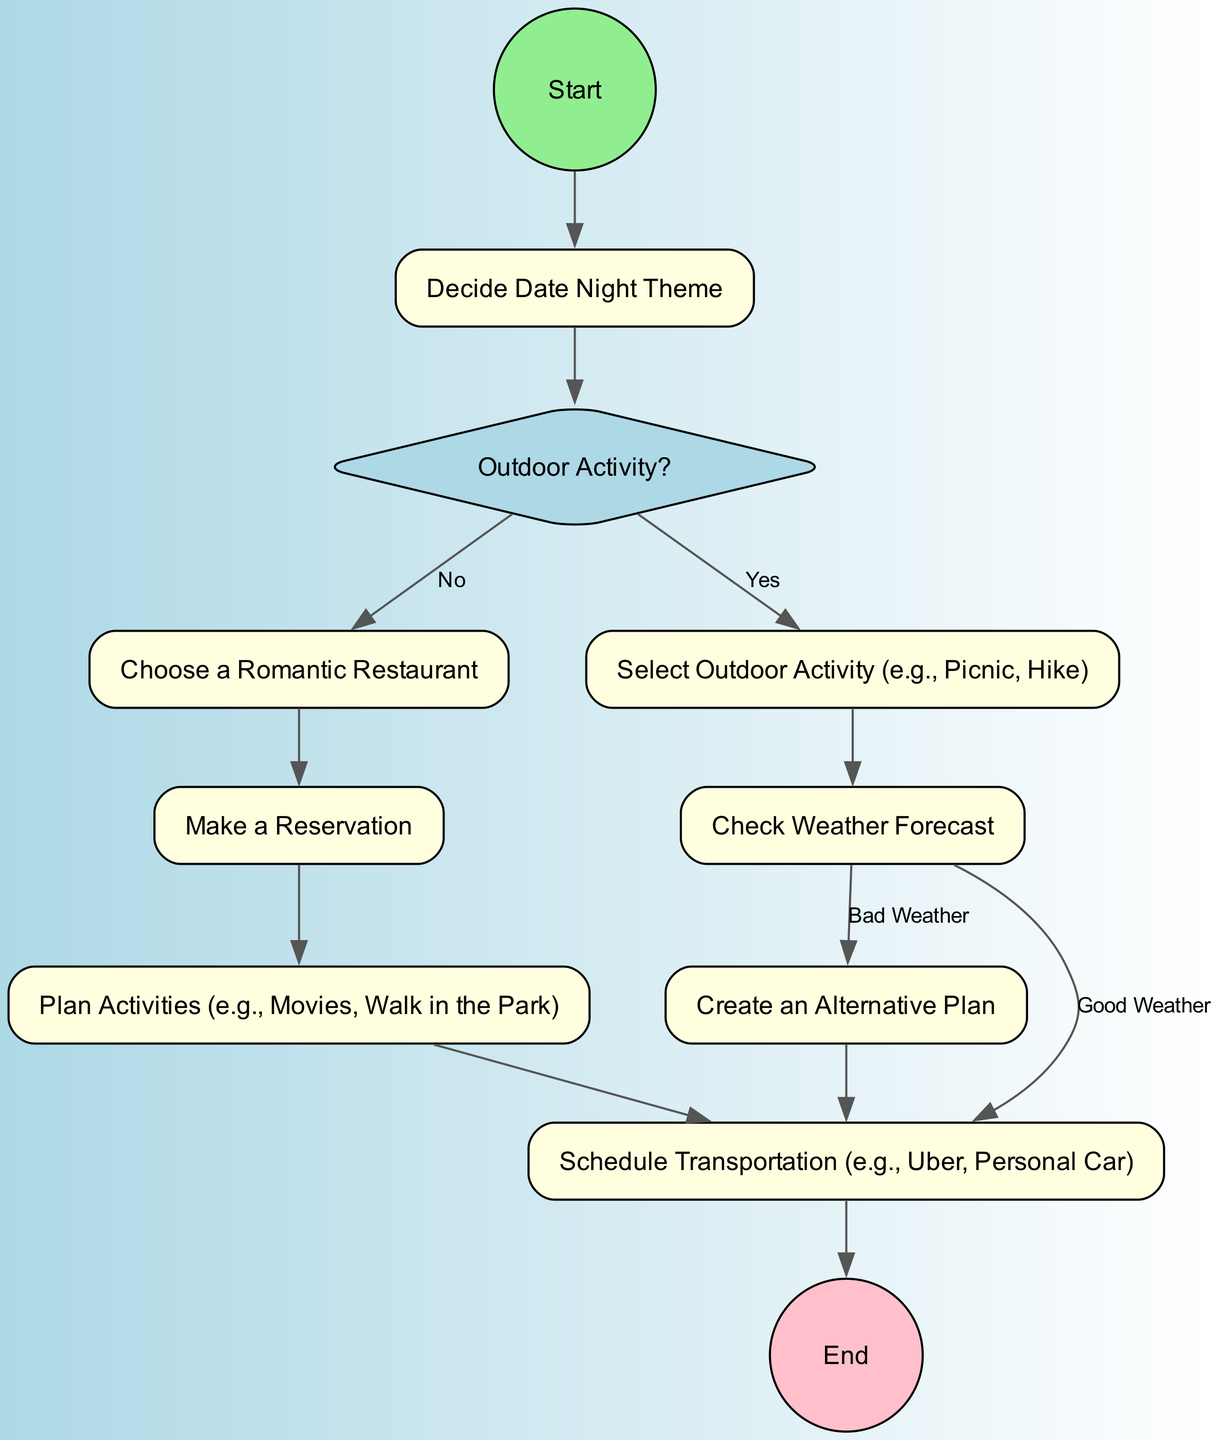What is the first step in planning the perfect date night? The first node in the diagram indicates that the initial step is "Start," which transitions directly to the action of deciding the date night theme.
Answer: Start How many activities are there after deciding on the date night theme? After deciding the date night theme, there are two paths: one leads to choosing a romantic restaurant, and the other leads to checking if an outdoor activity is desired, hence there are two main activities to consider next.
Answer: Two What is the condition for selecting outdoor activities? The decision node presents the question "Outdoor Activity?" and directs the flow based on the answer; if the answer is "Yes," it progresses to selecting an outdoor activity.
Answer: Yes What happens if the weather is bad? If the check weather forecast node indicates "Bad Weather," the flow leads to creating an alternative plan before proceeding to schedule transportation.
Answer: Create an Alternative Plan How do you proceed to schedule transportation after the check weather forecast? There are two outcomes from the check weather node; if the weather is "Good," it directly moves to scheduling transportation. If the weather is "Bad," it goes to creating an alternative plan first, then to scheduling transportation after that.
Answer: Schedule Transportation What is the final step in the diagram? The end node signifies that all planning has culminated and the procedure is complete, representing the end of the date night planning process.
Answer: End What is one activity that could be planned besides outdoor activities? The diagram mentions planning activities like "Movies, Walk in the Park," indicating that these are additional options for the date night beyond outdoor activities.
Answer: Movies What is the node immediately after making a reservation? The flow transitions from making a reservation to planning activities, which follows as the next action in the sequence.
Answer: Plan Activities What type of node is used for decision points in the diagram? The diagram employs diamond-shaped nodes to represent decision points, which are used to evaluate specific conditions like whether or not to engage in an outdoor activity.
Answer: Decision Node 